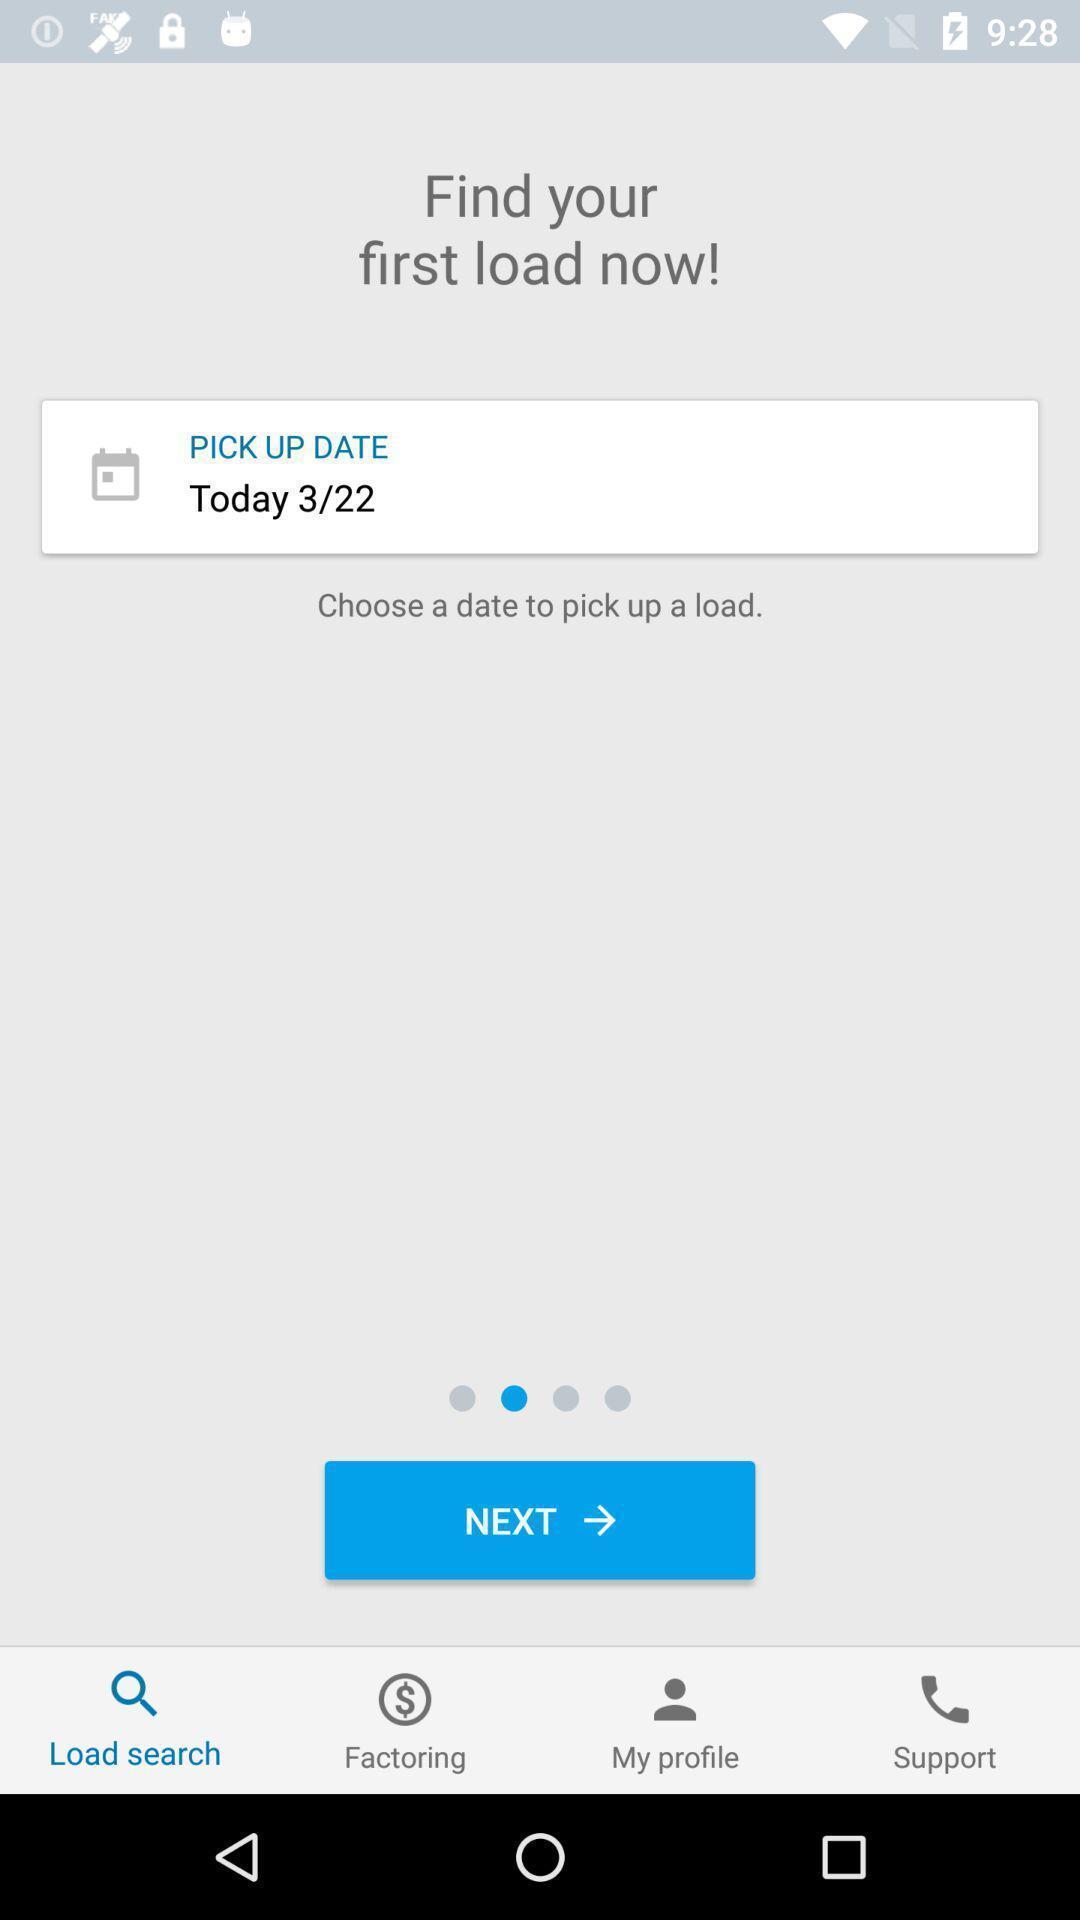Give me a summary of this screen capture. Pop up to pick date. 